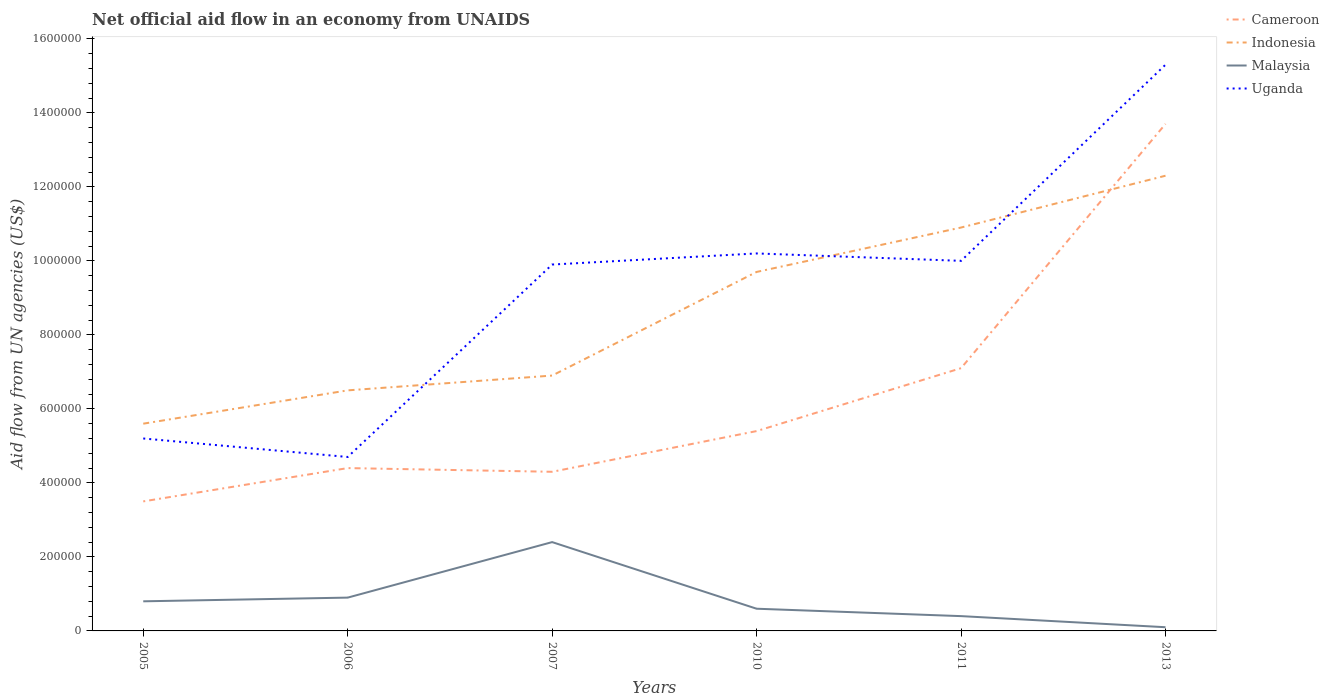How many different coloured lines are there?
Offer a terse response. 4. Does the line corresponding to Malaysia intersect with the line corresponding to Cameroon?
Keep it short and to the point. No. Across all years, what is the maximum net official aid flow in Cameroon?
Offer a very short reply. 3.50e+05. In which year was the net official aid flow in Malaysia maximum?
Your answer should be compact. 2013. What is the total net official aid flow in Malaysia in the graph?
Offer a very short reply. 2.30e+05. What is the difference between the highest and the second highest net official aid flow in Malaysia?
Your answer should be compact. 2.30e+05. How many lines are there?
Provide a short and direct response. 4. Are the values on the major ticks of Y-axis written in scientific E-notation?
Your response must be concise. No. Does the graph contain any zero values?
Your answer should be very brief. No. What is the title of the graph?
Your answer should be very brief. Net official aid flow in an economy from UNAIDS. Does "Nepal" appear as one of the legend labels in the graph?
Your response must be concise. No. What is the label or title of the Y-axis?
Your answer should be very brief. Aid flow from UN agencies (US$). What is the Aid flow from UN agencies (US$) in Cameroon in 2005?
Your response must be concise. 3.50e+05. What is the Aid flow from UN agencies (US$) of Indonesia in 2005?
Your answer should be compact. 5.60e+05. What is the Aid flow from UN agencies (US$) in Uganda in 2005?
Keep it short and to the point. 5.20e+05. What is the Aid flow from UN agencies (US$) of Cameroon in 2006?
Offer a terse response. 4.40e+05. What is the Aid flow from UN agencies (US$) in Indonesia in 2006?
Keep it short and to the point. 6.50e+05. What is the Aid flow from UN agencies (US$) of Malaysia in 2006?
Your response must be concise. 9.00e+04. What is the Aid flow from UN agencies (US$) in Indonesia in 2007?
Ensure brevity in your answer.  6.90e+05. What is the Aid flow from UN agencies (US$) of Malaysia in 2007?
Give a very brief answer. 2.40e+05. What is the Aid flow from UN agencies (US$) in Uganda in 2007?
Your response must be concise. 9.90e+05. What is the Aid flow from UN agencies (US$) in Cameroon in 2010?
Offer a terse response. 5.40e+05. What is the Aid flow from UN agencies (US$) in Indonesia in 2010?
Offer a terse response. 9.70e+05. What is the Aid flow from UN agencies (US$) in Malaysia in 2010?
Your answer should be very brief. 6.00e+04. What is the Aid flow from UN agencies (US$) of Uganda in 2010?
Offer a very short reply. 1.02e+06. What is the Aid flow from UN agencies (US$) in Cameroon in 2011?
Provide a succinct answer. 7.10e+05. What is the Aid flow from UN agencies (US$) of Indonesia in 2011?
Provide a short and direct response. 1.09e+06. What is the Aid flow from UN agencies (US$) of Uganda in 2011?
Offer a terse response. 1.00e+06. What is the Aid flow from UN agencies (US$) of Cameroon in 2013?
Keep it short and to the point. 1.37e+06. What is the Aid flow from UN agencies (US$) of Indonesia in 2013?
Your answer should be very brief. 1.23e+06. What is the Aid flow from UN agencies (US$) of Uganda in 2013?
Make the answer very short. 1.53e+06. Across all years, what is the maximum Aid flow from UN agencies (US$) in Cameroon?
Your answer should be compact. 1.37e+06. Across all years, what is the maximum Aid flow from UN agencies (US$) of Indonesia?
Offer a terse response. 1.23e+06. Across all years, what is the maximum Aid flow from UN agencies (US$) of Malaysia?
Make the answer very short. 2.40e+05. Across all years, what is the maximum Aid flow from UN agencies (US$) in Uganda?
Ensure brevity in your answer.  1.53e+06. Across all years, what is the minimum Aid flow from UN agencies (US$) in Cameroon?
Provide a succinct answer. 3.50e+05. Across all years, what is the minimum Aid flow from UN agencies (US$) of Indonesia?
Make the answer very short. 5.60e+05. Across all years, what is the minimum Aid flow from UN agencies (US$) of Malaysia?
Offer a terse response. 10000. Across all years, what is the minimum Aid flow from UN agencies (US$) in Uganda?
Ensure brevity in your answer.  4.70e+05. What is the total Aid flow from UN agencies (US$) of Cameroon in the graph?
Offer a very short reply. 3.84e+06. What is the total Aid flow from UN agencies (US$) of Indonesia in the graph?
Keep it short and to the point. 5.19e+06. What is the total Aid flow from UN agencies (US$) in Malaysia in the graph?
Offer a terse response. 5.20e+05. What is the total Aid flow from UN agencies (US$) of Uganda in the graph?
Provide a succinct answer. 5.53e+06. What is the difference between the Aid flow from UN agencies (US$) in Uganda in 2005 and that in 2006?
Provide a succinct answer. 5.00e+04. What is the difference between the Aid flow from UN agencies (US$) in Cameroon in 2005 and that in 2007?
Your answer should be compact. -8.00e+04. What is the difference between the Aid flow from UN agencies (US$) in Uganda in 2005 and that in 2007?
Your response must be concise. -4.70e+05. What is the difference between the Aid flow from UN agencies (US$) of Indonesia in 2005 and that in 2010?
Your answer should be very brief. -4.10e+05. What is the difference between the Aid flow from UN agencies (US$) of Uganda in 2005 and that in 2010?
Your answer should be very brief. -5.00e+05. What is the difference between the Aid flow from UN agencies (US$) in Cameroon in 2005 and that in 2011?
Provide a succinct answer. -3.60e+05. What is the difference between the Aid flow from UN agencies (US$) of Indonesia in 2005 and that in 2011?
Offer a terse response. -5.30e+05. What is the difference between the Aid flow from UN agencies (US$) in Uganda in 2005 and that in 2011?
Ensure brevity in your answer.  -4.80e+05. What is the difference between the Aid flow from UN agencies (US$) of Cameroon in 2005 and that in 2013?
Make the answer very short. -1.02e+06. What is the difference between the Aid flow from UN agencies (US$) of Indonesia in 2005 and that in 2013?
Give a very brief answer. -6.70e+05. What is the difference between the Aid flow from UN agencies (US$) of Malaysia in 2005 and that in 2013?
Make the answer very short. 7.00e+04. What is the difference between the Aid flow from UN agencies (US$) in Uganda in 2005 and that in 2013?
Make the answer very short. -1.01e+06. What is the difference between the Aid flow from UN agencies (US$) in Indonesia in 2006 and that in 2007?
Offer a very short reply. -4.00e+04. What is the difference between the Aid flow from UN agencies (US$) of Uganda in 2006 and that in 2007?
Offer a very short reply. -5.20e+05. What is the difference between the Aid flow from UN agencies (US$) in Indonesia in 2006 and that in 2010?
Provide a succinct answer. -3.20e+05. What is the difference between the Aid flow from UN agencies (US$) of Malaysia in 2006 and that in 2010?
Provide a succinct answer. 3.00e+04. What is the difference between the Aid flow from UN agencies (US$) in Uganda in 2006 and that in 2010?
Your answer should be very brief. -5.50e+05. What is the difference between the Aid flow from UN agencies (US$) in Indonesia in 2006 and that in 2011?
Your answer should be compact. -4.40e+05. What is the difference between the Aid flow from UN agencies (US$) of Malaysia in 2006 and that in 2011?
Ensure brevity in your answer.  5.00e+04. What is the difference between the Aid flow from UN agencies (US$) of Uganda in 2006 and that in 2011?
Make the answer very short. -5.30e+05. What is the difference between the Aid flow from UN agencies (US$) of Cameroon in 2006 and that in 2013?
Keep it short and to the point. -9.30e+05. What is the difference between the Aid flow from UN agencies (US$) in Indonesia in 2006 and that in 2013?
Offer a very short reply. -5.80e+05. What is the difference between the Aid flow from UN agencies (US$) of Malaysia in 2006 and that in 2013?
Provide a short and direct response. 8.00e+04. What is the difference between the Aid flow from UN agencies (US$) of Uganda in 2006 and that in 2013?
Ensure brevity in your answer.  -1.06e+06. What is the difference between the Aid flow from UN agencies (US$) of Cameroon in 2007 and that in 2010?
Provide a succinct answer. -1.10e+05. What is the difference between the Aid flow from UN agencies (US$) in Indonesia in 2007 and that in 2010?
Your answer should be very brief. -2.80e+05. What is the difference between the Aid flow from UN agencies (US$) of Malaysia in 2007 and that in 2010?
Your answer should be very brief. 1.80e+05. What is the difference between the Aid flow from UN agencies (US$) of Uganda in 2007 and that in 2010?
Your answer should be very brief. -3.00e+04. What is the difference between the Aid flow from UN agencies (US$) of Cameroon in 2007 and that in 2011?
Your answer should be very brief. -2.80e+05. What is the difference between the Aid flow from UN agencies (US$) of Indonesia in 2007 and that in 2011?
Your answer should be compact. -4.00e+05. What is the difference between the Aid flow from UN agencies (US$) in Cameroon in 2007 and that in 2013?
Your response must be concise. -9.40e+05. What is the difference between the Aid flow from UN agencies (US$) in Indonesia in 2007 and that in 2013?
Offer a very short reply. -5.40e+05. What is the difference between the Aid flow from UN agencies (US$) of Uganda in 2007 and that in 2013?
Offer a very short reply. -5.40e+05. What is the difference between the Aid flow from UN agencies (US$) of Cameroon in 2010 and that in 2011?
Your response must be concise. -1.70e+05. What is the difference between the Aid flow from UN agencies (US$) in Malaysia in 2010 and that in 2011?
Offer a very short reply. 2.00e+04. What is the difference between the Aid flow from UN agencies (US$) of Cameroon in 2010 and that in 2013?
Your response must be concise. -8.30e+05. What is the difference between the Aid flow from UN agencies (US$) in Indonesia in 2010 and that in 2013?
Keep it short and to the point. -2.60e+05. What is the difference between the Aid flow from UN agencies (US$) of Uganda in 2010 and that in 2013?
Offer a terse response. -5.10e+05. What is the difference between the Aid flow from UN agencies (US$) of Cameroon in 2011 and that in 2013?
Give a very brief answer. -6.60e+05. What is the difference between the Aid flow from UN agencies (US$) of Uganda in 2011 and that in 2013?
Keep it short and to the point. -5.30e+05. What is the difference between the Aid flow from UN agencies (US$) of Cameroon in 2005 and the Aid flow from UN agencies (US$) of Uganda in 2006?
Provide a short and direct response. -1.20e+05. What is the difference between the Aid flow from UN agencies (US$) of Malaysia in 2005 and the Aid flow from UN agencies (US$) of Uganda in 2006?
Make the answer very short. -3.90e+05. What is the difference between the Aid flow from UN agencies (US$) of Cameroon in 2005 and the Aid flow from UN agencies (US$) of Indonesia in 2007?
Give a very brief answer. -3.40e+05. What is the difference between the Aid flow from UN agencies (US$) of Cameroon in 2005 and the Aid flow from UN agencies (US$) of Malaysia in 2007?
Keep it short and to the point. 1.10e+05. What is the difference between the Aid flow from UN agencies (US$) of Cameroon in 2005 and the Aid flow from UN agencies (US$) of Uganda in 2007?
Your response must be concise. -6.40e+05. What is the difference between the Aid flow from UN agencies (US$) of Indonesia in 2005 and the Aid flow from UN agencies (US$) of Uganda in 2007?
Make the answer very short. -4.30e+05. What is the difference between the Aid flow from UN agencies (US$) of Malaysia in 2005 and the Aid flow from UN agencies (US$) of Uganda in 2007?
Make the answer very short. -9.10e+05. What is the difference between the Aid flow from UN agencies (US$) in Cameroon in 2005 and the Aid flow from UN agencies (US$) in Indonesia in 2010?
Offer a very short reply. -6.20e+05. What is the difference between the Aid flow from UN agencies (US$) in Cameroon in 2005 and the Aid flow from UN agencies (US$) in Uganda in 2010?
Make the answer very short. -6.70e+05. What is the difference between the Aid flow from UN agencies (US$) in Indonesia in 2005 and the Aid flow from UN agencies (US$) in Malaysia in 2010?
Your answer should be compact. 5.00e+05. What is the difference between the Aid flow from UN agencies (US$) in Indonesia in 2005 and the Aid flow from UN agencies (US$) in Uganda in 2010?
Provide a succinct answer. -4.60e+05. What is the difference between the Aid flow from UN agencies (US$) of Malaysia in 2005 and the Aid flow from UN agencies (US$) of Uganda in 2010?
Provide a succinct answer. -9.40e+05. What is the difference between the Aid flow from UN agencies (US$) of Cameroon in 2005 and the Aid flow from UN agencies (US$) of Indonesia in 2011?
Ensure brevity in your answer.  -7.40e+05. What is the difference between the Aid flow from UN agencies (US$) in Cameroon in 2005 and the Aid flow from UN agencies (US$) in Uganda in 2011?
Your answer should be very brief. -6.50e+05. What is the difference between the Aid flow from UN agencies (US$) in Indonesia in 2005 and the Aid flow from UN agencies (US$) in Malaysia in 2011?
Ensure brevity in your answer.  5.20e+05. What is the difference between the Aid flow from UN agencies (US$) of Indonesia in 2005 and the Aid flow from UN agencies (US$) of Uganda in 2011?
Make the answer very short. -4.40e+05. What is the difference between the Aid flow from UN agencies (US$) of Malaysia in 2005 and the Aid flow from UN agencies (US$) of Uganda in 2011?
Provide a short and direct response. -9.20e+05. What is the difference between the Aid flow from UN agencies (US$) of Cameroon in 2005 and the Aid flow from UN agencies (US$) of Indonesia in 2013?
Your answer should be very brief. -8.80e+05. What is the difference between the Aid flow from UN agencies (US$) of Cameroon in 2005 and the Aid flow from UN agencies (US$) of Malaysia in 2013?
Ensure brevity in your answer.  3.40e+05. What is the difference between the Aid flow from UN agencies (US$) of Cameroon in 2005 and the Aid flow from UN agencies (US$) of Uganda in 2013?
Keep it short and to the point. -1.18e+06. What is the difference between the Aid flow from UN agencies (US$) of Indonesia in 2005 and the Aid flow from UN agencies (US$) of Malaysia in 2013?
Ensure brevity in your answer.  5.50e+05. What is the difference between the Aid flow from UN agencies (US$) of Indonesia in 2005 and the Aid flow from UN agencies (US$) of Uganda in 2013?
Provide a short and direct response. -9.70e+05. What is the difference between the Aid flow from UN agencies (US$) of Malaysia in 2005 and the Aid flow from UN agencies (US$) of Uganda in 2013?
Provide a succinct answer. -1.45e+06. What is the difference between the Aid flow from UN agencies (US$) in Cameroon in 2006 and the Aid flow from UN agencies (US$) in Malaysia in 2007?
Offer a very short reply. 2.00e+05. What is the difference between the Aid flow from UN agencies (US$) of Cameroon in 2006 and the Aid flow from UN agencies (US$) of Uganda in 2007?
Your answer should be very brief. -5.50e+05. What is the difference between the Aid flow from UN agencies (US$) of Indonesia in 2006 and the Aid flow from UN agencies (US$) of Malaysia in 2007?
Your response must be concise. 4.10e+05. What is the difference between the Aid flow from UN agencies (US$) of Malaysia in 2006 and the Aid flow from UN agencies (US$) of Uganda in 2007?
Your response must be concise. -9.00e+05. What is the difference between the Aid flow from UN agencies (US$) of Cameroon in 2006 and the Aid flow from UN agencies (US$) of Indonesia in 2010?
Your response must be concise. -5.30e+05. What is the difference between the Aid flow from UN agencies (US$) of Cameroon in 2006 and the Aid flow from UN agencies (US$) of Uganda in 2010?
Keep it short and to the point. -5.80e+05. What is the difference between the Aid flow from UN agencies (US$) of Indonesia in 2006 and the Aid flow from UN agencies (US$) of Malaysia in 2010?
Provide a short and direct response. 5.90e+05. What is the difference between the Aid flow from UN agencies (US$) in Indonesia in 2006 and the Aid flow from UN agencies (US$) in Uganda in 2010?
Your answer should be compact. -3.70e+05. What is the difference between the Aid flow from UN agencies (US$) in Malaysia in 2006 and the Aid flow from UN agencies (US$) in Uganda in 2010?
Your answer should be compact. -9.30e+05. What is the difference between the Aid flow from UN agencies (US$) of Cameroon in 2006 and the Aid flow from UN agencies (US$) of Indonesia in 2011?
Provide a succinct answer. -6.50e+05. What is the difference between the Aid flow from UN agencies (US$) in Cameroon in 2006 and the Aid flow from UN agencies (US$) in Uganda in 2011?
Keep it short and to the point. -5.60e+05. What is the difference between the Aid flow from UN agencies (US$) in Indonesia in 2006 and the Aid flow from UN agencies (US$) in Uganda in 2011?
Your response must be concise. -3.50e+05. What is the difference between the Aid flow from UN agencies (US$) of Malaysia in 2006 and the Aid flow from UN agencies (US$) of Uganda in 2011?
Your answer should be very brief. -9.10e+05. What is the difference between the Aid flow from UN agencies (US$) of Cameroon in 2006 and the Aid flow from UN agencies (US$) of Indonesia in 2013?
Ensure brevity in your answer.  -7.90e+05. What is the difference between the Aid flow from UN agencies (US$) in Cameroon in 2006 and the Aid flow from UN agencies (US$) in Uganda in 2013?
Ensure brevity in your answer.  -1.09e+06. What is the difference between the Aid flow from UN agencies (US$) of Indonesia in 2006 and the Aid flow from UN agencies (US$) of Malaysia in 2013?
Ensure brevity in your answer.  6.40e+05. What is the difference between the Aid flow from UN agencies (US$) in Indonesia in 2006 and the Aid flow from UN agencies (US$) in Uganda in 2013?
Offer a very short reply. -8.80e+05. What is the difference between the Aid flow from UN agencies (US$) in Malaysia in 2006 and the Aid flow from UN agencies (US$) in Uganda in 2013?
Make the answer very short. -1.44e+06. What is the difference between the Aid flow from UN agencies (US$) of Cameroon in 2007 and the Aid flow from UN agencies (US$) of Indonesia in 2010?
Provide a short and direct response. -5.40e+05. What is the difference between the Aid flow from UN agencies (US$) of Cameroon in 2007 and the Aid flow from UN agencies (US$) of Uganda in 2010?
Your answer should be very brief. -5.90e+05. What is the difference between the Aid flow from UN agencies (US$) of Indonesia in 2007 and the Aid flow from UN agencies (US$) of Malaysia in 2010?
Keep it short and to the point. 6.30e+05. What is the difference between the Aid flow from UN agencies (US$) in Indonesia in 2007 and the Aid flow from UN agencies (US$) in Uganda in 2010?
Offer a very short reply. -3.30e+05. What is the difference between the Aid flow from UN agencies (US$) in Malaysia in 2007 and the Aid flow from UN agencies (US$) in Uganda in 2010?
Give a very brief answer. -7.80e+05. What is the difference between the Aid flow from UN agencies (US$) in Cameroon in 2007 and the Aid flow from UN agencies (US$) in Indonesia in 2011?
Ensure brevity in your answer.  -6.60e+05. What is the difference between the Aid flow from UN agencies (US$) of Cameroon in 2007 and the Aid flow from UN agencies (US$) of Uganda in 2011?
Provide a succinct answer. -5.70e+05. What is the difference between the Aid flow from UN agencies (US$) in Indonesia in 2007 and the Aid flow from UN agencies (US$) in Malaysia in 2011?
Give a very brief answer. 6.50e+05. What is the difference between the Aid flow from UN agencies (US$) in Indonesia in 2007 and the Aid flow from UN agencies (US$) in Uganda in 2011?
Provide a succinct answer. -3.10e+05. What is the difference between the Aid flow from UN agencies (US$) of Malaysia in 2007 and the Aid flow from UN agencies (US$) of Uganda in 2011?
Your answer should be compact. -7.60e+05. What is the difference between the Aid flow from UN agencies (US$) of Cameroon in 2007 and the Aid flow from UN agencies (US$) of Indonesia in 2013?
Your answer should be compact. -8.00e+05. What is the difference between the Aid flow from UN agencies (US$) in Cameroon in 2007 and the Aid flow from UN agencies (US$) in Uganda in 2013?
Your response must be concise. -1.10e+06. What is the difference between the Aid flow from UN agencies (US$) of Indonesia in 2007 and the Aid flow from UN agencies (US$) of Malaysia in 2013?
Offer a terse response. 6.80e+05. What is the difference between the Aid flow from UN agencies (US$) of Indonesia in 2007 and the Aid flow from UN agencies (US$) of Uganda in 2013?
Your answer should be very brief. -8.40e+05. What is the difference between the Aid flow from UN agencies (US$) in Malaysia in 2007 and the Aid flow from UN agencies (US$) in Uganda in 2013?
Offer a very short reply. -1.29e+06. What is the difference between the Aid flow from UN agencies (US$) in Cameroon in 2010 and the Aid flow from UN agencies (US$) in Indonesia in 2011?
Give a very brief answer. -5.50e+05. What is the difference between the Aid flow from UN agencies (US$) of Cameroon in 2010 and the Aid flow from UN agencies (US$) of Uganda in 2011?
Your answer should be very brief. -4.60e+05. What is the difference between the Aid flow from UN agencies (US$) of Indonesia in 2010 and the Aid flow from UN agencies (US$) of Malaysia in 2011?
Keep it short and to the point. 9.30e+05. What is the difference between the Aid flow from UN agencies (US$) in Malaysia in 2010 and the Aid flow from UN agencies (US$) in Uganda in 2011?
Offer a terse response. -9.40e+05. What is the difference between the Aid flow from UN agencies (US$) in Cameroon in 2010 and the Aid flow from UN agencies (US$) in Indonesia in 2013?
Ensure brevity in your answer.  -6.90e+05. What is the difference between the Aid flow from UN agencies (US$) of Cameroon in 2010 and the Aid flow from UN agencies (US$) of Malaysia in 2013?
Offer a very short reply. 5.30e+05. What is the difference between the Aid flow from UN agencies (US$) of Cameroon in 2010 and the Aid flow from UN agencies (US$) of Uganda in 2013?
Ensure brevity in your answer.  -9.90e+05. What is the difference between the Aid flow from UN agencies (US$) of Indonesia in 2010 and the Aid flow from UN agencies (US$) of Malaysia in 2013?
Your answer should be compact. 9.60e+05. What is the difference between the Aid flow from UN agencies (US$) of Indonesia in 2010 and the Aid flow from UN agencies (US$) of Uganda in 2013?
Your response must be concise. -5.60e+05. What is the difference between the Aid flow from UN agencies (US$) in Malaysia in 2010 and the Aid flow from UN agencies (US$) in Uganda in 2013?
Offer a very short reply. -1.47e+06. What is the difference between the Aid flow from UN agencies (US$) of Cameroon in 2011 and the Aid flow from UN agencies (US$) of Indonesia in 2013?
Give a very brief answer. -5.20e+05. What is the difference between the Aid flow from UN agencies (US$) of Cameroon in 2011 and the Aid flow from UN agencies (US$) of Malaysia in 2013?
Provide a succinct answer. 7.00e+05. What is the difference between the Aid flow from UN agencies (US$) of Cameroon in 2011 and the Aid flow from UN agencies (US$) of Uganda in 2013?
Ensure brevity in your answer.  -8.20e+05. What is the difference between the Aid flow from UN agencies (US$) of Indonesia in 2011 and the Aid flow from UN agencies (US$) of Malaysia in 2013?
Your answer should be very brief. 1.08e+06. What is the difference between the Aid flow from UN agencies (US$) in Indonesia in 2011 and the Aid flow from UN agencies (US$) in Uganda in 2013?
Your response must be concise. -4.40e+05. What is the difference between the Aid flow from UN agencies (US$) in Malaysia in 2011 and the Aid flow from UN agencies (US$) in Uganda in 2013?
Provide a short and direct response. -1.49e+06. What is the average Aid flow from UN agencies (US$) in Cameroon per year?
Keep it short and to the point. 6.40e+05. What is the average Aid flow from UN agencies (US$) of Indonesia per year?
Your answer should be compact. 8.65e+05. What is the average Aid flow from UN agencies (US$) of Malaysia per year?
Your response must be concise. 8.67e+04. What is the average Aid flow from UN agencies (US$) of Uganda per year?
Your answer should be very brief. 9.22e+05. In the year 2005, what is the difference between the Aid flow from UN agencies (US$) of Cameroon and Aid flow from UN agencies (US$) of Malaysia?
Offer a very short reply. 2.70e+05. In the year 2005, what is the difference between the Aid flow from UN agencies (US$) of Cameroon and Aid flow from UN agencies (US$) of Uganda?
Make the answer very short. -1.70e+05. In the year 2005, what is the difference between the Aid flow from UN agencies (US$) in Indonesia and Aid flow from UN agencies (US$) in Uganda?
Your answer should be very brief. 4.00e+04. In the year 2005, what is the difference between the Aid flow from UN agencies (US$) in Malaysia and Aid flow from UN agencies (US$) in Uganda?
Ensure brevity in your answer.  -4.40e+05. In the year 2006, what is the difference between the Aid flow from UN agencies (US$) in Cameroon and Aid flow from UN agencies (US$) in Indonesia?
Your answer should be very brief. -2.10e+05. In the year 2006, what is the difference between the Aid flow from UN agencies (US$) in Indonesia and Aid flow from UN agencies (US$) in Malaysia?
Provide a succinct answer. 5.60e+05. In the year 2006, what is the difference between the Aid flow from UN agencies (US$) of Indonesia and Aid flow from UN agencies (US$) of Uganda?
Give a very brief answer. 1.80e+05. In the year 2006, what is the difference between the Aid flow from UN agencies (US$) of Malaysia and Aid flow from UN agencies (US$) of Uganda?
Your answer should be compact. -3.80e+05. In the year 2007, what is the difference between the Aid flow from UN agencies (US$) in Cameroon and Aid flow from UN agencies (US$) in Indonesia?
Provide a short and direct response. -2.60e+05. In the year 2007, what is the difference between the Aid flow from UN agencies (US$) of Cameroon and Aid flow from UN agencies (US$) of Uganda?
Ensure brevity in your answer.  -5.60e+05. In the year 2007, what is the difference between the Aid flow from UN agencies (US$) in Indonesia and Aid flow from UN agencies (US$) in Malaysia?
Your answer should be very brief. 4.50e+05. In the year 2007, what is the difference between the Aid flow from UN agencies (US$) in Malaysia and Aid flow from UN agencies (US$) in Uganda?
Your answer should be very brief. -7.50e+05. In the year 2010, what is the difference between the Aid flow from UN agencies (US$) in Cameroon and Aid flow from UN agencies (US$) in Indonesia?
Your answer should be very brief. -4.30e+05. In the year 2010, what is the difference between the Aid flow from UN agencies (US$) of Cameroon and Aid flow from UN agencies (US$) of Uganda?
Offer a very short reply. -4.80e+05. In the year 2010, what is the difference between the Aid flow from UN agencies (US$) of Indonesia and Aid flow from UN agencies (US$) of Malaysia?
Provide a short and direct response. 9.10e+05. In the year 2010, what is the difference between the Aid flow from UN agencies (US$) of Indonesia and Aid flow from UN agencies (US$) of Uganda?
Ensure brevity in your answer.  -5.00e+04. In the year 2010, what is the difference between the Aid flow from UN agencies (US$) in Malaysia and Aid flow from UN agencies (US$) in Uganda?
Your response must be concise. -9.60e+05. In the year 2011, what is the difference between the Aid flow from UN agencies (US$) in Cameroon and Aid flow from UN agencies (US$) in Indonesia?
Offer a very short reply. -3.80e+05. In the year 2011, what is the difference between the Aid flow from UN agencies (US$) of Cameroon and Aid flow from UN agencies (US$) of Malaysia?
Your answer should be very brief. 6.70e+05. In the year 2011, what is the difference between the Aid flow from UN agencies (US$) of Indonesia and Aid flow from UN agencies (US$) of Malaysia?
Give a very brief answer. 1.05e+06. In the year 2011, what is the difference between the Aid flow from UN agencies (US$) in Malaysia and Aid flow from UN agencies (US$) in Uganda?
Ensure brevity in your answer.  -9.60e+05. In the year 2013, what is the difference between the Aid flow from UN agencies (US$) of Cameroon and Aid flow from UN agencies (US$) of Malaysia?
Ensure brevity in your answer.  1.36e+06. In the year 2013, what is the difference between the Aid flow from UN agencies (US$) of Indonesia and Aid flow from UN agencies (US$) of Malaysia?
Your answer should be compact. 1.22e+06. In the year 2013, what is the difference between the Aid flow from UN agencies (US$) in Malaysia and Aid flow from UN agencies (US$) in Uganda?
Offer a terse response. -1.52e+06. What is the ratio of the Aid flow from UN agencies (US$) of Cameroon in 2005 to that in 2006?
Your answer should be compact. 0.8. What is the ratio of the Aid flow from UN agencies (US$) of Indonesia in 2005 to that in 2006?
Make the answer very short. 0.86. What is the ratio of the Aid flow from UN agencies (US$) of Uganda in 2005 to that in 2006?
Provide a short and direct response. 1.11. What is the ratio of the Aid flow from UN agencies (US$) of Cameroon in 2005 to that in 2007?
Provide a succinct answer. 0.81. What is the ratio of the Aid flow from UN agencies (US$) in Indonesia in 2005 to that in 2007?
Make the answer very short. 0.81. What is the ratio of the Aid flow from UN agencies (US$) in Uganda in 2005 to that in 2007?
Give a very brief answer. 0.53. What is the ratio of the Aid flow from UN agencies (US$) in Cameroon in 2005 to that in 2010?
Your answer should be very brief. 0.65. What is the ratio of the Aid flow from UN agencies (US$) in Indonesia in 2005 to that in 2010?
Offer a terse response. 0.58. What is the ratio of the Aid flow from UN agencies (US$) of Uganda in 2005 to that in 2010?
Offer a very short reply. 0.51. What is the ratio of the Aid flow from UN agencies (US$) of Cameroon in 2005 to that in 2011?
Ensure brevity in your answer.  0.49. What is the ratio of the Aid flow from UN agencies (US$) in Indonesia in 2005 to that in 2011?
Give a very brief answer. 0.51. What is the ratio of the Aid flow from UN agencies (US$) in Malaysia in 2005 to that in 2011?
Ensure brevity in your answer.  2. What is the ratio of the Aid flow from UN agencies (US$) of Uganda in 2005 to that in 2011?
Offer a terse response. 0.52. What is the ratio of the Aid flow from UN agencies (US$) in Cameroon in 2005 to that in 2013?
Ensure brevity in your answer.  0.26. What is the ratio of the Aid flow from UN agencies (US$) of Indonesia in 2005 to that in 2013?
Your answer should be compact. 0.46. What is the ratio of the Aid flow from UN agencies (US$) in Uganda in 2005 to that in 2013?
Offer a very short reply. 0.34. What is the ratio of the Aid flow from UN agencies (US$) of Cameroon in 2006 to that in 2007?
Ensure brevity in your answer.  1.02. What is the ratio of the Aid flow from UN agencies (US$) in Indonesia in 2006 to that in 2007?
Your answer should be very brief. 0.94. What is the ratio of the Aid flow from UN agencies (US$) of Malaysia in 2006 to that in 2007?
Keep it short and to the point. 0.38. What is the ratio of the Aid flow from UN agencies (US$) in Uganda in 2006 to that in 2007?
Give a very brief answer. 0.47. What is the ratio of the Aid flow from UN agencies (US$) of Cameroon in 2006 to that in 2010?
Keep it short and to the point. 0.81. What is the ratio of the Aid flow from UN agencies (US$) of Indonesia in 2006 to that in 2010?
Make the answer very short. 0.67. What is the ratio of the Aid flow from UN agencies (US$) in Malaysia in 2006 to that in 2010?
Ensure brevity in your answer.  1.5. What is the ratio of the Aid flow from UN agencies (US$) in Uganda in 2006 to that in 2010?
Ensure brevity in your answer.  0.46. What is the ratio of the Aid flow from UN agencies (US$) in Cameroon in 2006 to that in 2011?
Provide a short and direct response. 0.62. What is the ratio of the Aid flow from UN agencies (US$) of Indonesia in 2006 to that in 2011?
Make the answer very short. 0.6. What is the ratio of the Aid flow from UN agencies (US$) in Malaysia in 2006 to that in 2011?
Your answer should be very brief. 2.25. What is the ratio of the Aid flow from UN agencies (US$) of Uganda in 2006 to that in 2011?
Ensure brevity in your answer.  0.47. What is the ratio of the Aid flow from UN agencies (US$) in Cameroon in 2006 to that in 2013?
Give a very brief answer. 0.32. What is the ratio of the Aid flow from UN agencies (US$) of Indonesia in 2006 to that in 2013?
Your response must be concise. 0.53. What is the ratio of the Aid flow from UN agencies (US$) of Uganda in 2006 to that in 2013?
Offer a terse response. 0.31. What is the ratio of the Aid flow from UN agencies (US$) in Cameroon in 2007 to that in 2010?
Give a very brief answer. 0.8. What is the ratio of the Aid flow from UN agencies (US$) of Indonesia in 2007 to that in 2010?
Your answer should be compact. 0.71. What is the ratio of the Aid flow from UN agencies (US$) of Malaysia in 2007 to that in 2010?
Give a very brief answer. 4. What is the ratio of the Aid flow from UN agencies (US$) of Uganda in 2007 to that in 2010?
Keep it short and to the point. 0.97. What is the ratio of the Aid flow from UN agencies (US$) of Cameroon in 2007 to that in 2011?
Your answer should be very brief. 0.61. What is the ratio of the Aid flow from UN agencies (US$) of Indonesia in 2007 to that in 2011?
Make the answer very short. 0.63. What is the ratio of the Aid flow from UN agencies (US$) of Cameroon in 2007 to that in 2013?
Provide a short and direct response. 0.31. What is the ratio of the Aid flow from UN agencies (US$) in Indonesia in 2007 to that in 2013?
Your response must be concise. 0.56. What is the ratio of the Aid flow from UN agencies (US$) of Uganda in 2007 to that in 2013?
Make the answer very short. 0.65. What is the ratio of the Aid flow from UN agencies (US$) of Cameroon in 2010 to that in 2011?
Offer a terse response. 0.76. What is the ratio of the Aid flow from UN agencies (US$) of Indonesia in 2010 to that in 2011?
Your answer should be very brief. 0.89. What is the ratio of the Aid flow from UN agencies (US$) of Malaysia in 2010 to that in 2011?
Offer a very short reply. 1.5. What is the ratio of the Aid flow from UN agencies (US$) in Cameroon in 2010 to that in 2013?
Provide a succinct answer. 0.39. What is the ratio of the Aid flow from UN agencies (US$) of Indonesia in 2010 to that in 2013?
Your response must be concise. 0.79. What is the ratio of the Aid flow from UN agencies (US$) in Cameroon in 2011 to that in 2013?
Ensure brevity in your answer.  0.52. What is the ratio of the Aid flow from UN agencies (US$) in Indonesia in 2011 to that in 2013?
Your response must be concise. 0.89. What is the ratio of the Aid flow from UN agencies (US$) in Uganda in 2011 to that in 2013?
Your answer should be very brief. 0.65. What is the difference between the highest and the second highest Aid flow from UN agencies (US$) in Malaysia?
Ensure brevity in your answer.  1.50e+05. What is the difference between the highest and the second highest Aid flow from UN agencies (US$) of Uganda?
Your answer should be compact. 5.10e+05. What is the difference between the highest and the lowest Aid flow from UN agencies (US$) of Cameroon?
Your answer should be very brief. 1.02e+06. What is the difference between the highest and the lowest Aid flow from UN agencies (US$) in Indonesia?
Offer a terse response. 6.70e+05. What is the difference between the highest and the lowest Aid flow from UN agencies (US$) in Uganda?
Your answer should be compact. 1.06e+06. 